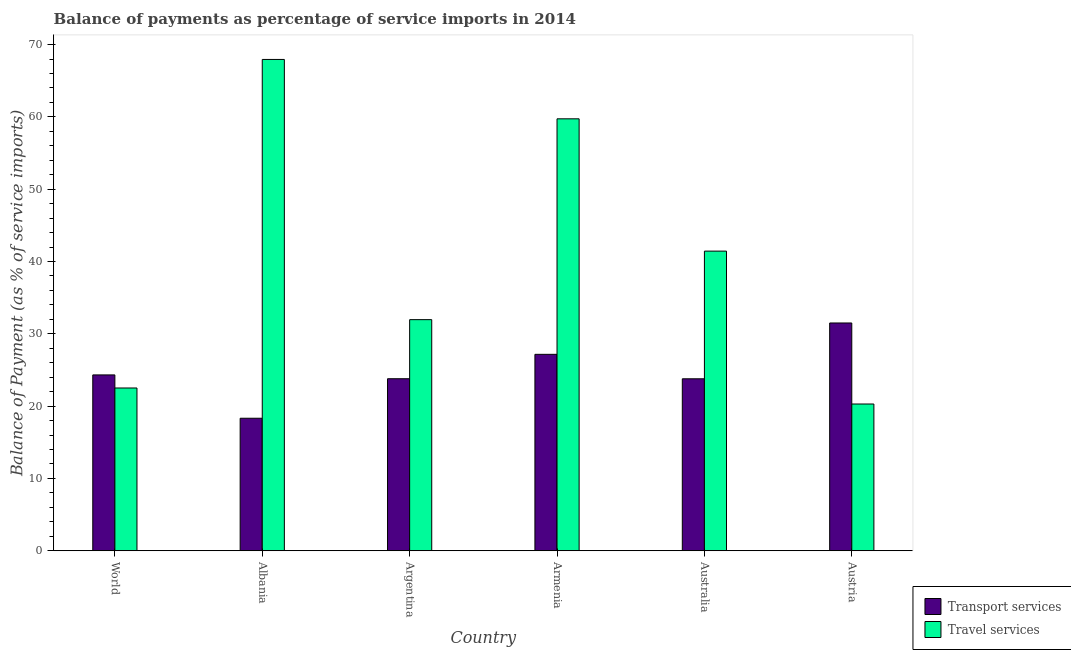Are the number of bars per tick equal to the number of legend labels?
Your response must be concise. Yes. Are the number of bars on each tick of the X-axis equal?
Provide a succinct answer. Yes. How many bars are there on the 6th tick from the left?
Provide a succinct answer. 2. What is the label of the 2nd group of bars from the left?
Keep it short and to the point. Albania. In how many cases, is the number of bars for a given country not equal to the number of legend labels?
Provide a short and direct response. 0. What is the balance of payments of transport services in Australia?
Offer a terse response. 23.78. Across all countries, what is the maximum balance of payments of travel services?
Your response must be concise. 67.94. Across all countries, what is the minimum balance of payments of travel services?
Provide a short and direct response. 20.3. In which country was the balance of payments of travel services maximum?
Ensure brevity in your answer.  Albania. In which country was the balance of payments of travel services minimum?
Keep it short and to the point. Austria. What is the total balance of payments of travel services in the graph?
Provide a succinct answer. 243.88. What is the difference between the balance of payments of travel services in Albania and that in Armenia?
Your response must be concise. 8.21. What is the difference between the balance of payments of travel services in World and the balance of payments of transport services in Austria?
Ensure brevity in your answer.  -8.99. What is the average balance of payments of transport services per country?
Ensure brevity in your answer.  24.81. What is the difference between the balance of payments of transport services and balance of payments of travel services in Argentina?
Make the answer very short. -8.17. What is the ratio of the balance of payments of travel services in Albania to that in Armenia?
Ensure brevity in your answer.  1.14. What is the difference between the highest and the second highest balance of payments of transport services?
Make the answer very short. 4.34. What is the difference between the highest and the lowest balance of payments of travel services?
Provide a short and direct response. 47.65. Is the sum of the balance of payments of transport services in Austria and World greater than the maximum balance of payments of travel services across all countries?
Offer a terse response. No. What does the 1st bar from the left in Armenia represents?
Your answer should be compact. Transport services. What does the 2nd bar from the right in World represents?
Your answer should be very brief. Transport services. How many bars are there?
Give a very brief answer. 12. Are the values on the major ticks of Y-axis written in scientific E-notation?
Your answer should be compact. No. How many legend labels are there?
Offer a terse response. 2. How are the legend labels stacked?
Provide a short and direct response. Vertical. What is the title of the graph?
Offer a very short reply. Balance of payments as percentage of service imports in 2014. Does "Net National savings" appear as one of the legend labels in the graph?
Offer a terse response. No. What is the label or title of the X-axis?
Your answer should be compact. Country. What is the label or title of the Y-axis?
Offer a terse response. Balance of Payment (as % of service imports). What is the Balance of Payment (as % of service imports) of Transport services in World?
Offer a very short reply. 24.32. What is the Balance of Payment (as % of service imports) in Travel services in World?
Provide a succinct answer. 22.51. What is the Balance of Payment (as % of service imports) in Transport services in Albania?
Ensure brevity in your answer.  18.33. What is the Balance of Payment (as % of service imports) in Travel services in Albania?
Keep it short and to the point. 67.94. What is the Balance of Payment (as % of service imports) in Transport services in Argentina?
Keep it short and to the point. 23.79. What is the Balance of Payment (as % of service imports) in Travel services in Argentina?
Your answer should be compact. 31.96. What is the Balance of Payment (as % of service imports) of Transport services in Armenia?
Ensure brevity in your answer.  27.17. What is the Balance of Payment (as % of service imports) in Travel services in Armenia?
Provide a short and direct response. 59.73. What is the Balance of Payment (as % of service imports) of Transport services in Australia?
Provide a succinct answer. 23.78. What is the Balance of Payment (as % of service imports) in Travel services in Australia?
Provide a succinct answer. 41.44. What is the Balance of Payment (as % of service imports) of Transport services in Austria?
Provide a short and direct response. 31.5. What is the Balance of Payment (as % of service imports) in Travel services in Austria?
Your answer should be very brief. 20.3. Across all countries, what is the maximum Balance of Payment (as % of service imports) in Transport services?
Offer a terse response. 31.5. Across all countries, what is the maximum Balance of Payment (as % of service imports) of Travel services?
Give a very brief answer. 67.94. Across all countries, what is the minimum Balance of Payment (as % of service imports) in Transport services?
Keep it short and to the point. 18.33. Across all countries, what is the minimum Balance of Payment (as % of service imports) in Travel services?
Provide a succinct answer. 20.3. What is the total Balance of Payment (as % of service imports) of Transport services in the graph?
Your response must be concise. 148.89. What is the total Balance of Payment (as % of service imports) of Travel services in the graph?
Your answer should be compact. 243.88. What is the difference between the Balance of Payment (as % of service imports) in Transport services in World and that in Albania?
Make the answer very short. 5.99. What is the difference between the Balance of Payment (as % of service imports) in Travel services in World and that in Albania?
Ensure brevity in your answer.  -45.43. What is the difference between the Balance of Payment (as % of service imports) in Transport services in World and that in Argentina?
Ensure brevity in your answer.  0.53. What is the difference between the Balance of Payment (as % of service imports) of Travel services in World and that in Argentina?
Keep it short and to the point. -9.45. What is the difference between the Balance of Payment (as % of service imports) of Transport services in World and that in Armenia?
Your response must be concise. -2.85. What is the difference between the Balance of Payment (as % of service imports) of Travel services in World and that in Armenia?
Your answer should be compact. -37.22. What is the difference between the Balance of Payment (as % of service imports) of Transport services in World and that in Australia?
Offer a very short reply. 0.54. What is the difference between the Balance of Payment (as % of service imports) of Travel services in World and that in Australia?
Ensure brevity in your answer.  -18.93. What is the difference between the Balance of Payment (as % of service imports) in Transport services in World and that in Austria?
Give a very brief answer. -7.18. What is the difference between the Balance of Payment (as % of service imports) in Travel services in World and that in Austria?
Give a very brief answer. 2.21. What is the difference between the Balance of Payment (as % of service imports) in Transport services in Albania and that in Argentina?
Offer a terse response. -5.46. What is the difference between the Balance of Payment (as % of service imports) of Travel services in Albania and that in Argentina?
Your answer should be compact. 35.98. What is the difference between the Balance of Payment (as % of service imports) of Transport services in Albania and that in Armenia?
Your answer should be compact. -8.84. What is the difference between the Balance of Payment (as % of service imports) of Travel services in Albania and that in Armenia?
Provide a succinct answer. 8.21. What is the difference between the Balance of Payment (as % of service imports) of Transport services in Albania and that in Australia?
Offer a terse response. -5.46. What is the difference between the Balance of Payment (as % of service imports) in Travel services in Albania and that in Australia?
Your answer should be compact. 26.51. What is the difference between the Balance of Payment (as % of service imports) of Transport services in Albania and that in Austria?
Offer a very short reply. -13.17. What is the difference between the Balance of Payment (as % of service imports) of Travel services in Albania and that in Austria?
Your answer should be very brief. 47.65. What is the difference between the Balance of Payment (as % of service imports) in Transport services in Argentina and that in Armenia?
Your answer should be very brief. -3.37. What is the difference between the Balance of Payment (as % of service imports) in Travel services in Argentina and that in Armenia?
Your answer should be compact. -27.77. What is the difference between the Balance of Payment (as % of service imports) in Transport services in Argentina and that in Australia?
Your answer should be compact. 0.01. What is the difference between the Balance of Payment (as % of service imports) in Travel services in Argentina and that in Australia?
Your answer should be very brief. -9.48. What is the difference between the Balance of Payment (as % of service imports) in Transport services in Argentina and that in Austria?
Offer a terse response. -7.71. What is the difference between the Balance of Payment (as % of service imports) in Travel services in Argentina and that in Austria?
Ensure brevity in your answer.  11.66. What is the difference between the Balance of Payment (as % of service imports) of Transport services in Armenia and that in Australia?
Provide a succinct answer. 3.38. What is the difference between the Balance of Payment (as % of service imports) in Travel services in Armenia and that in Australia?
Provide a short and direct response. 18.29. What is the difference between the Balance of Payment (as % of service imports) in Transport services in Armenia and that in Austria?
Offer a terse response. -4.34. What is the difference between the Balance of Payment (as % of service imports) of Travel services in Armenia and that in Austria?
Your response must be concise. 39.44. What is the difference between the Balance of Payment (as % of service imports) of Transport services in Australia and that in Austria?
Keep it short and to the point. -7.72. What is the difference between the Balance of Payment (as % of service imports) in Travel services in Australia and that in Austria?
Offer a terse response. 21.14. What is the difference between the Balance of Payment (as % of service imports) of Transport services in World and the Balance of Payment (as % of service imports) of Travel services in Albania?
Ensure brevity in your answer.  -43.63. What is the difference between the Balance of Payment (as % of service imports) in Transport services in World and the Balance of Payment (as % of service imports) in Travel services in Argentina?
Provide a succinct answer. -7.64. What is the difference between the Balance of Payment (as % of service imports) of Transport services in World and the Balance of Payment (as % of service imports) of Travel services in Armenia?
Offer a terse response. -35.41. What is the difference between the Balance of Payment (as % of service imports) of Transport services in World and the Balance of Payment (as % of service imports) of Travel services in Australia?
Make the answer very short. -17.12. What is the difference between the Balance of Payment (as % of service imports) of Transport services in World and the Balance of Payment (as % of service imports) of Travel services in Austria?
Your answer should be very brief. 4.02. What is the difference between the Balance of Payment (as % of service imports) of Transport services in Albania and the Balance of Payment (as % of service imports) of Travel services in Argentina?
Give a very brief answer. -13.63. What is the difference between the Balance of Payment (as % of service imports) in Transport services in Albania and the Balance of Payment (as % of service imports) in Travel services in Armenia?
Provide a succinct answer. -41.41. What is the difference between the Balance of Payment (as % of service imports) of Transport services in Albania and the Balance of Payment (as % of service imports) of Travel services in Australia?
Provide a succinct answer. -23.11. What is the difference between the Balance of Payment (as % of service imports) of Transport services in Albania and the Balance of Payment (as % of service imports) of Travel services in Austria?
Provide a short and direct response. -1.97. What is the difference between the Balance of Payment (as % of service imports) in Transport services in Argentina and the Balance of Payment (as % of service imports) in Travel services in Armenia?
Your answer should be compact. -35.94. What is the difference between the Balance of Payment (as % of service imports) of Transport services in Argentina and the Balance of Payment (as % of service imports) of Travel services in Australia?
Your answer should be compact. -17.65. What is the difference between the Balance of Payment (as % of service imports) of Transport services in Argentina and the Balance of Payment (as % of service imports) of Travel services in Austria?
Your response must be concise. 3.49. What is the difference between the Balance of Payment (as % of service imports) in Transport services in Armenia and the Balance of Payment (as % of service imports) in Travel services in Australia?
Your response must be concise. -14.27. What is the difference between the Balance of Payment (as % of service imports) of Transport services in Armenia and the Balance of Payment (as % of service imports) of Travel services in Austria?
Give a very brief answer. 6.87. What is the difference between the Balance of Payment (as % of service imports) in Transport services in Australia and the Balance of Payment (as % of service imports) in Travel services in Austria?
Make the answer very short. 3.49. What is the average Balance of Payment (as % of service imports) of Transport services per country?
Your response must be concise. 24.81. What is the average Balance of Payment (as % of service imports) of Travel services per country?
Offer a terse response. 40.65. What is the difference between the Balance of Payment (as % of service imports) of Transport services and Balance of Payment (as % of service imports) of Travel services in World?
Provide a succinct answer. 1.81. What is the difference between the Balance of Payment (as % of service imports) of Transport services and Balance of Payment (as % of service imports) of Travel services in Albania?
Offer a very short reply. -49.62. What is the difference between the Balance of Payment (as % of service imports) in Transport services and Balance of Payment (as % of service imports) in Travel services in Argentina?
Keep it short and to the point. -8.17. What is the difference between the Balance of Payment (as % of service imports) of Transport services and Balance of Payment (as % of service imports) of Travel services in Armenia?
Ensure brevity in your answer.  -32.57. What is the difference between the Balance of Payment (as % of service imports) of Transport services and Balance of Payment (as % of service imports) of Travel services in Australia?
Your response must be concise. -17.65. What is the difference between the Balance of Payment (as % of service imports) of Transport services and Balance of Payment (as % of service imports) of Travel services in Austria?
Ensure brevity in your answer.  11.2. What is the ratio of the Balance of Payment (as % of service imports) of Transport services in World to that in Albania?
Keep it short and to the point. 1.33. What is the ratio of the Balance of Payment (as % of service imports) in Travel services in World to that in Albania?
Your answer should be very brief. 0.33. What is the ratio of the Balance of Payment (as % of service imports) in Transport services in World to that in Argentina?
Offer a terse response. 1.02. What is the ratio of the Balance of Payment (as % of service imports) of Travel services in World to that in Argentina?
Your answer should be compact. 0.7. What is the ratio of the Balance of Payment (as % of service imports) in Transport services in World to that in Armenia?
Offer a terse response. 0.9. What is the ratio of the Balance of Payment (as % of service imports) in Travel services in World to that in Armenia?
Provide a short and direct response. 0.38. What is the ratio of the Balance of Payment (as % of service imports) of Transport services in World to that in Australia?
Your answer should be very brief. 1.02. What is the ratio of the Balance of Payment (as % of service imports) of Travel services in World to that in Australia?
Offer a very short reply. 0.54. What is the ratio of the Balance of Payment (as % of service imports) of Transport services in World to that in Austria?
Ensure brevity in your answer.  0.77. What is the ratio of the Balance of Payment (as % of service imports) in Travel services in World to that in Austria?
Ensure brevity in your answer.  1.11. What is the ratio of the Balance of Payment (as % of service imports) in Transport services in Albania to that in Argentina?
Your answer should be compact. 0.77. What is the ratio of the Balance of Payment (as % of service imports) in Travel services in Albania to that in Argentina?
Offer a very short reply. 2.13. What is the ratio of the Balance of Payment (as % of service imports) of Transport services in Albania to that in Armenia?
Offer a very short reply. 0.67. What is the ratio of the Balance of Payment (as % of service imports) of Travel services in Albania to that in Armenia?
Ensure brevity in your answer.  1.14. What is the ratio of the Balance of Payment (as % of service imports) of Transport services in Albania to that in Australia?
Your response must be concise. 0.77. What is the ratio of the Balance of Payment (as % of service imports) in Travel services in Albania to that in Australia?
Your response must be concise. 1.64. What is the ratio of the Balance of Payment (as % of service imports) in Transport services in Albania to that in Austria?
Make the answer very short. 0.58. What is the ratio of the Balance of Payment (as % of service imports) in Travel services in Albania to that in Austria?
Offer a very short reply. 3.35. What is the ratio of the Balance of Payment (as % of service imports) of Transport services in Argentina to that in Armenia?
Provide a short and direct response. 0.88. What is the ratio of the Balance of Payment (as % of service imports) in Travel services in Argentina to that in Armenia?
Offer a very short reply. 0.54. What is the ratio of the Balance of Payment (as % of service imports) in Travel services in Argentina to that in Australia?
Your response must be concise. 0.77. What is the ratio of the Balance of Payment (as % of service imports) in Transport services in Argentina to that in Austria?
Provide a short and direct response. 0.76. What is the ratio of the Balance of Payment (as % of service imports) of Travel services in Argentina to that in Austria?
Your response must be concise. 1.57. What is the ratio of the Balance of Payment (as % of service imports) of Transport services in Armenia to that in Australia?
Provide a succinct answer. 1.14. What is the ratio of the Balance of Payment (as % of service imports) of Travel services in Armenia to that in Australia?
Make the answer very short. 1.44. What is the ratio of the Balance of Payment (as % of service imports) of Transport services in Armenia to that in Austria?
Provide a succinct answer. 0.86. What is the ratio of the Balance of Payment (as % of service imports) of Travel services in Armenia to that in Austria?
Your answer should be very brief. 2.94. What is the ratio of the Balance of Payment (as % of service imports) of Transport services in Australia to that in Austria?
Make the answer very short. 0.76. What is the ratio of the Balance of Payment (as % of service imports) of Travel services in Australia to that in Austria?
Provide a short and direct response. 2.04. What is the difference between the highest and the second highest Balance of Payment (as % of service imports) in Transport services?
Provide a short and direct response. 4.34. What is the difference between the highest and the second highest Balance of Payment (as % of service imports) of Travel services?
Ensure brevity in your answer.  8.21. What is the difference between the highest and the lowest Balance of Payment (as % of service imports) of Transport services?
Your response must be concise. 13.17. What is the difference between the highest and the lowest Balance of Payment (as % of service imports) in Travel services?
Make the answer very short. 47.65. 